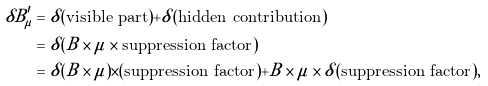<formula> <loc_0><loc_0><loc_500><loc_500>\delta B _ { \mu } ^ { \prime } & = \delta ( \text {visible part} ) + \delta ( \text {hidden contribution} ) \\ & = \delta ( B \times \mu \times \text {suppression factor} ) \\ & = \delta ( B \times \mu ) \times ( \text {suppression factor} ) + B \times \mu \times \delta ( \text {suppression factor} ) ,</formula> 